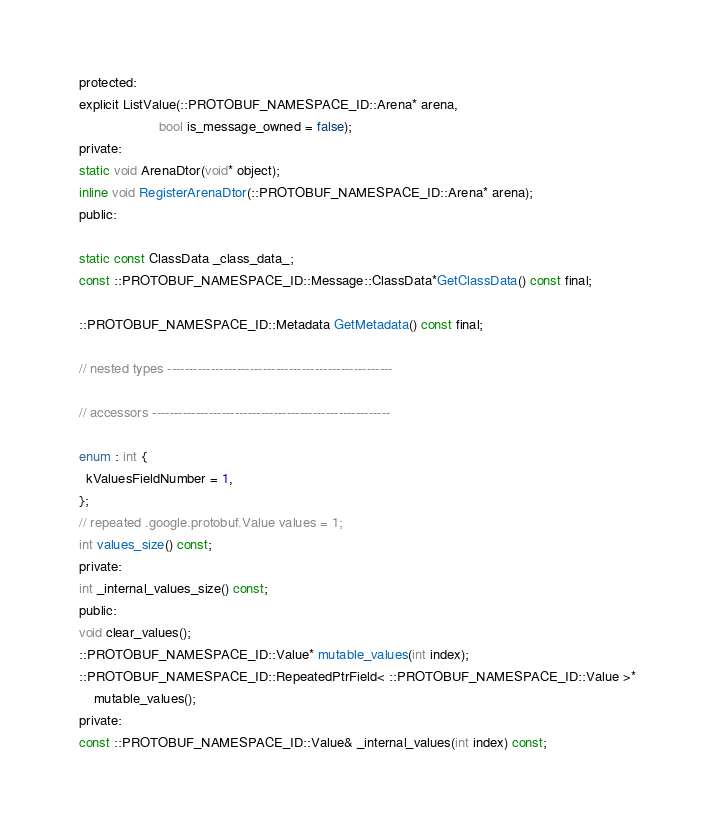<code> <loc_0><loc_0><loc_500><loc_500><_C_>  protected:
  explicit ListValue(::PROTOBUF_NAMESPACE_ID::Arena* arena,
                       bool is_message_owned = false);
  private:
  static void ArenaDtor(void* object);
  inline void RegisterArenaDtor(::PROTOBUF_NAMESPACE_ID::Arena* arena);
  public:

  static const ClassData _class_data_;
  const ::PROTOBUF_NAMESPACE_ID::Message::ClassData*GetClassData() const final;

  ::PROTOBUF_NAMESPACE_ID::Metadata GetMetadata() const final;

  // nested types ----------------------------------------------------

  // accessors -------------------------------------------------------

  enum : int {
    kValuesFieldNumber = 1,
  };
  // repeated .google.protobuf.Value values = 1;
  int values_size() const;
  private:
  int _internal_values_size() const;
  public:
  void clear_values();
  ::PROTOBUF_NAMESPACE_ID::Value* mutable_values(int index);
  ::PROTOBUF_NAMESPACE_ID::RepeatedPtrField< ::PROTOBUF_NAMESPACE_ID::Value >*
      mutable_values();
  private:
  const ::PROTOBUF_NAMESPACE_ID::Value& _internal_values(int index) const;</code> 